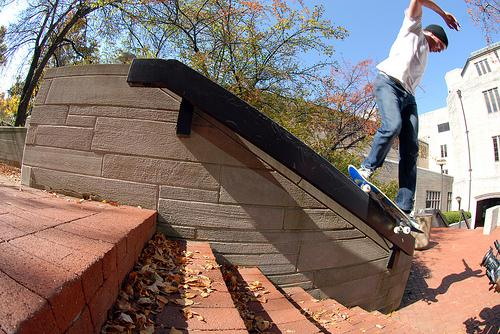Question: what is the man doing?
Choices:
A. Going down a railing.
B. Running.
C. Jogging up hill.
D. Biking.
Answer with the letter. Answer: A Question: when was the photo taken?
Choices:
A. At night.
B. In the morning.
C. Yesterday.
D. During the day.
Answer with the letter. Answer: D Question: why is the man there?
Choices:
A. To swim.
B. To swing.
C. To ride his skateboard.
D. To ride bikes.
Answer with the letter. Answer: C Question: what is in the background?
Choices:
A. Trees.
B. Mountains.
C. A building.
D. Hills.
Answer with the letter. Answer: C 